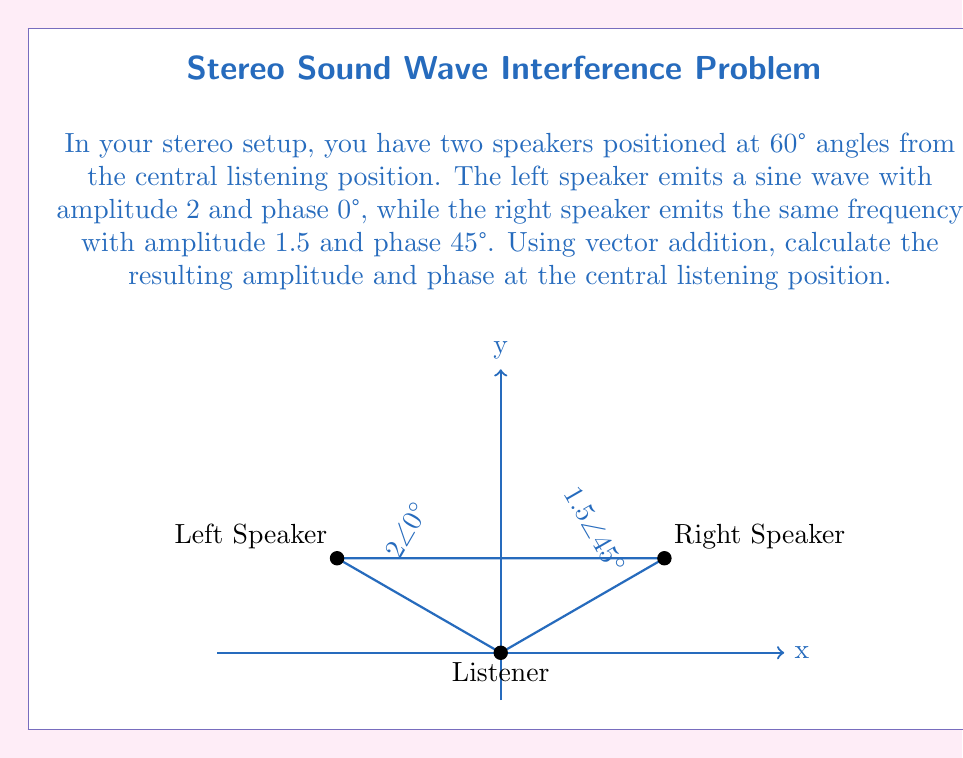Provide a solution to this math problem. Let's approach this step-by-step:

1) First, we need to convert the polar form of the vectors to rectangular form:

   Left speaker: $2\angle 0°$ = $2 + 0i$
   Right speaker: $1.5\angle 45°$ = $1.5(\cos 45° + i\sin 45°)$ = $1.5(\frac{\sqrt{2}}{2} + i\frac{\sqrt{2}}{2})$ = $1.06 + 1.06i$

2) Now, we add these vectors:

   $(2 + 0i) + (1.06 + 1.06i) = 3.06 + 1.06i$

3) To find the amplitude of the resulting vector, we calculate its magnitude:

   $\text{Amplitude} = \sqrt{3.06^2 + 1.06^2} = \sqrt{10.4772} \approx 3.24$

4) To find the phase, we calculate the arctangent of the imaginary part divided by the real part:

   $\text{Phase} = \tan^{-1}(\frac{1.06}{3.06}) \approx 19.1°$

5) Therefore, the resulting vector at the listening position is approximately $3.24\angle 19.1°$.
Answer: $3.24\angle 19.1°$ 